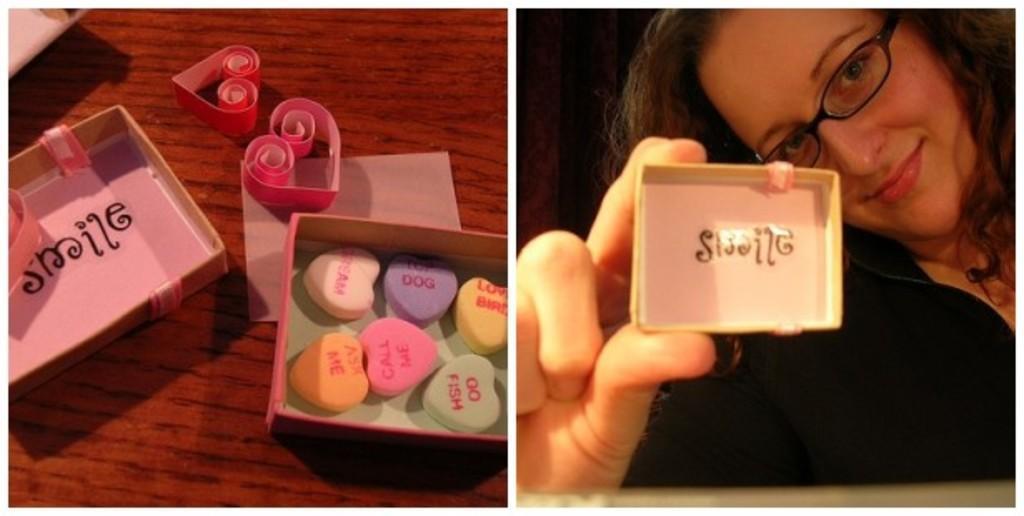Can you describe this image briefly? This is a collage picture. In the left side of the image, I can see candies in a box and there are paper items on the table. In the right side of the image there is a woman smiling and holding an object. 